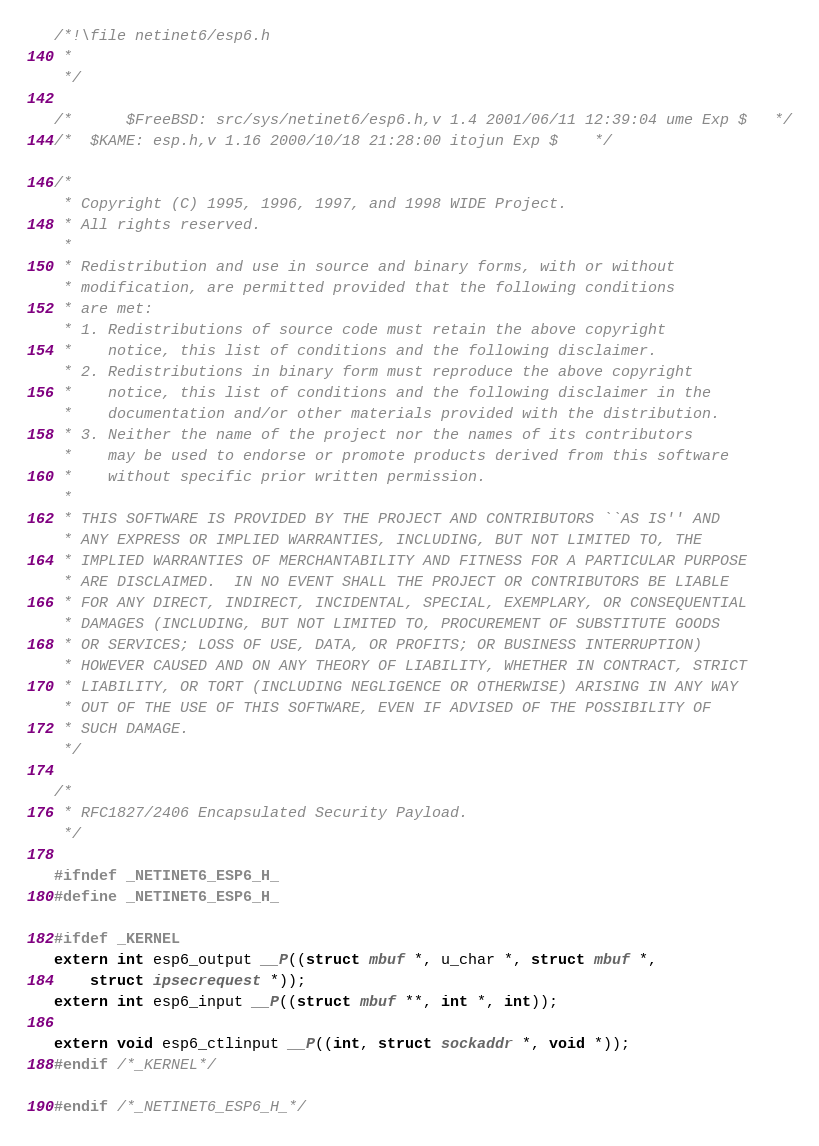<code> <loc_0><loc_0><loc_500><loc_500><_C_>/*!\file netinet6/esp6.h
 *
 */

/*      $FreeBSD: src/sys/netinet6/esp6.h,v 1.4 2001/06/11 12:39:04 ume Exp $   */
/*	$KAME: esp.h,v 1.16 2000/10/18 21:28:00 itojun Exp $	*/

/*
 * Copyright (C) 1995, 1996, 1997, and 1998 WIDE Project.
 * All rights reserved.
 *
 * Redistribution and use in source and binary forms, with or without
 * modification, are permitted provided that the following conditions
 * are met:
 * 1. Redistributions of source code must retain the above copyright
 *    notice, this list of conditions and the following disclaimer.
 * 2. Redistributions in binary form must reproduce the above copyright
 *    notice, this list of conditions and the following disclaimer in the
 *    documentation and/or other materials provided with the distribution.
 * 3. Neither the name of the project nor the names of its contributors
 *    may be used to endorse or promote products derived from this software
 *    without specific prior written permission.
 *
 * THIS SOFTWARE IS PROVIDED BY THE PROJECT AND CONTRIBUTORS ``AS IS'' AND
 * ANY EXPRESS OR IMPLIED WARRANTIES, INCLUDING, BUT NOT LIMITED TO, THE
 * IMPLIED WARRANTIES OF MERCHANTABILITY AND FITNESS FOR A PARTICULAR PURPOSE
 * ARE DISCLAIMED.  IN NO EVENT SHALL THE PROJECT OR CONTRIBUTORS BE LIABLE
 * FOR ANY DIRECT, INDIRECT, INCIDENTAL, SPECIAL, EXEMPLARY, OR CONSEQUENTIAL
 * DAMAGES (INCLUDING, BUT NOT LIMITED TO, PROCUREMENT OF SUBSTITUTE GOODS
 * OR SERVICES; LOSS OF USE, DATA, OR PROFITS; OR BUSINESS INTERRUPTION)
 * HOWEVER CAUSED AND ON ANY THEORY OF LIABILITY, WHETHER IN CONTRACT, STRICT
 * LIABILITY, OR TORT (INCLUDING NEGLIGENCE OR OTHERWISE) ARISING IN ANY WAY
 * OUT OF THE USE OF THIS SOFTWARE, EVEN IF ADVISED OF THE POSSIBILITY OF
 * SUCH DAMAGE.
 */

/*
 * RFC1827/2406 Encapsulated Security Payload.
 */

#ifndef _NETINET6_ESP6_H_
#define _NETINET6_ESP6_H_

#ifdef _KERNEL
extern int esp6_output __P((struct mbuf *, u_char *, struct mbuf *,
	struct ipsecrequest *));
extern int esp6_input __P((struct mbuf **, int *, int));

extern void esp6_ctlinput __P((int, struct sockaddr *, void *));
#endif /*_KERNEL*/

#endif /*_NETINET6_ESP6_H_*/
</code> 